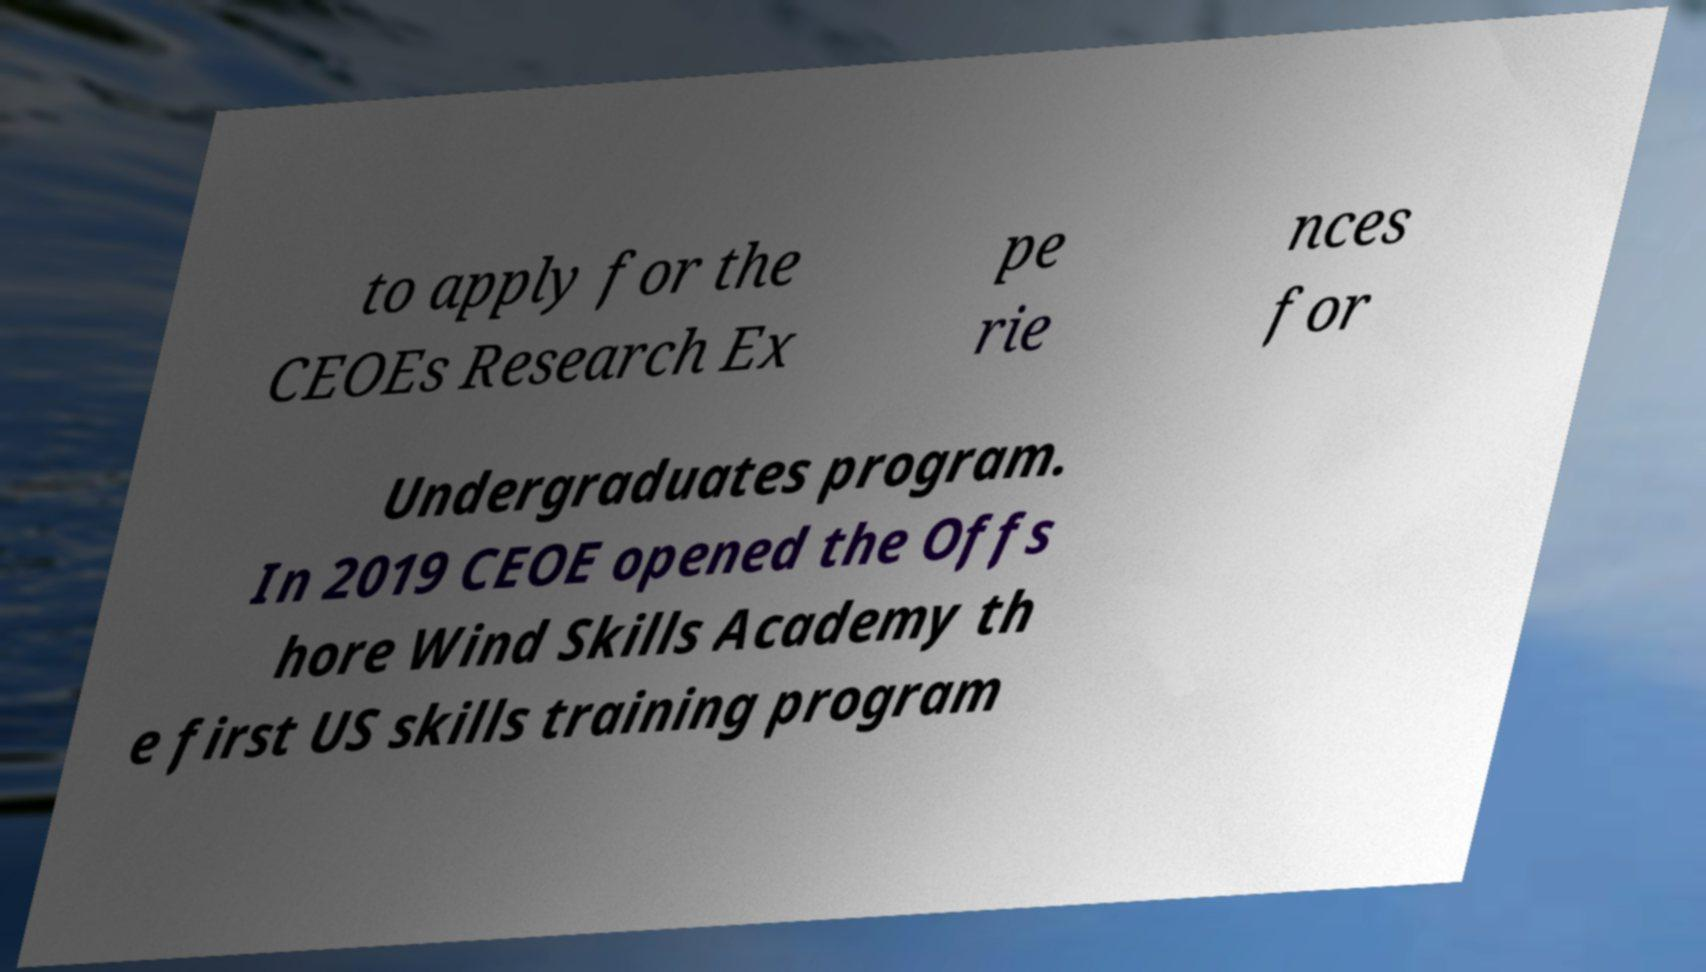Can you accurately transcribe the text from the provided image for me? to apply for the CEOEs Research Ex pe rie nces for Undergraduates program. In 2019 CEOE opened the Offs hore Wind Skills Academy th e first US skills training program 